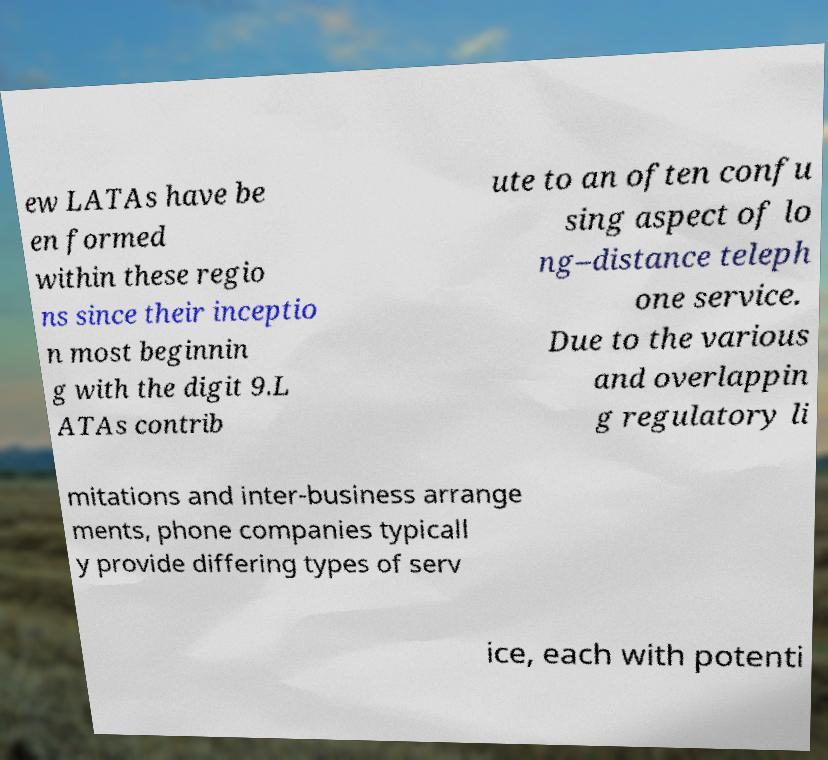Can you read and provide the text displayed in the image?This photo seems to have some interesting text. Can you extract and type it out for me? ew LATAs have be en formed within these regio ns since their inceptio n most beginnin g with the digit 9.L ATAs contrib ute to an often confu sing aspect of lo ng–distance teleph one service. Due to the various and overlappin g regulatory li mitations and inter-business arrange ments, phone companies typicall y provide differing types of serv ice, each with potenti 